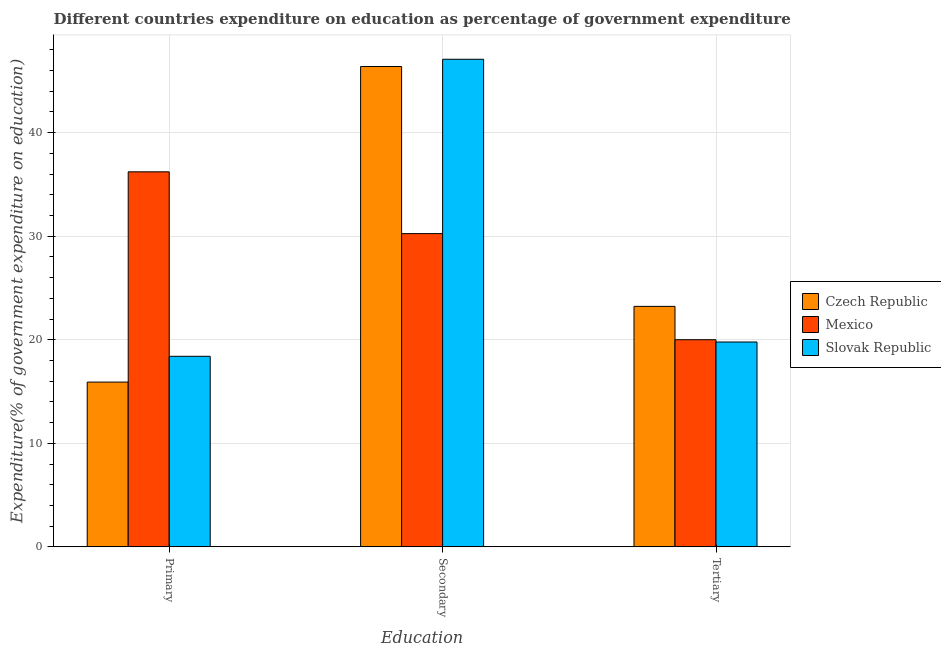How many different coloured bars are there?
Ensure brevity in your answer.  3. Are the number of bars on each tick of the X-axis equal?
Make the answer very short. Yes. How many bars are there on the 1st tick from the left?
Ensure brevity in your answer.  3. How many bars are there on the 2nd tick from the right?
Your response must be concise. 3. What is the label of the 3rd group of bars from the left?
Make the answer very short. Tertiary. What is the expenditure on tertiary education in Slovak Republic?
Keep it short and to the point. 19.78. Across all countries, what is the maximum expenditure on tertiary education?
Make the answer very short. 23.22. Across all countries, what is the minimum expenditure on tertiary education?
Ensure brevity in your answer.  19.78. In which country was the expenditure on primary education maximum?
Offer a very short reply. Mexico. What is the total expenditure on primary education in the graph?
Offer a terse response. 70.53. What is the difference between the expenditure on primary education in Czech Republic and that in Slovak Republic?
Your answer should be compact. -2.49. What is the difference between the expenditure on secondary education in Slovak Republic and the expenditure on primary education in Czech Republic?
Ensure brevity in your answer.  31.17. What is the average expenditure on tertiary education per country?
Your answer should be compact. 21. What is the difference between the expenditure on primary education and expenditure on tertiary education in Mexico?
Give a very brief answer. 16.21. What is the ratio of the expenditure on secondary education in Slovak Republic to that in Mexico?
Make the answer very short. 1.56. Is the difference between the expenditure on primary education in Czech Republic and Mexico greater than the difference between the expenditure on secondary education in Czech Republic and Mexico?
Offer a terse response. No. What is the difference between the highest and the second highest expenditure on tertiary education?
Offer a very short reply. 3.22. What is the difference between the highest and the lowest expenditure on primary education?
Offer a very short reply. 20.3. Is the sum of the expenditure on primary education in Mexico and Czech Republic greater than the maximum expenditure on tertiary education across all countries?
Provide a succinct answer. Yes. What does the 2nd bar from the left in Primary represents?
Your answer should be compact. Mexico. What does the 3rd bar from the right in Secondary represents?
Keep it short and to the point. Czech Republic. Is it the case that in every country, the sum of the expenditure on primary education and expenditure on secondary education is greater than the expenditure on tertiary education?
Your response must be concise. Yes. Are all the bars in the graph horizontal?
Offer a terse response. No. What is the difference between two consecutive major ticks on the Y-axis?
Your response must be concise. 10. Does the graph contain any zero values?
Ensure brevity in your answer.  No. Does the graph contain grids?
Provide a short and direct response. Yes. Where does the legend appear in the graph?
Your answer should be very brief. Center right. What is the title of the graph?
Ensure brevity in your answer.  Different countries expenditure on education as percentage of government expenditure. Does "Korea (Republic)" appear as one of the legend labels in the graph?
Make the answer very short. No. What is the label or title of the X-axis?
Offer a very short reply. Education. What is the label or title of the Y-axis?
Offer a terse response. Expenditure(% of government expenditure on education). What is the Expenditure(% of government expenditure on education) in Czech Republic in Primary?
Your response must be concise. 15.91. What is the Expenditure(% of government expenditure on education) in Mexico in Primary?
Your answer should be compact. 36.22. What is the Expenditure(% of government expenditure on education) of Slovak Republic in Primary?
Provide a succinct answer. 18.4. What is the Expenditure(% of government expenditure on education) of Czech Republic in Secondary?
Keep it short and to the point. 46.39. What is the Expenditure(% of government expenditure on education) in Mexico in Secondary?
Offer a very short reply. 30.25. What is the Expenditure(% of government expenditure on education) of Slovak Republic in Secondary?
Ensure brevity in your answer.  47.09. What is the Expenditure(% of government expenditure on education) of Czech Republic in Tertiary?
Offer a very short reply. 23.22. What is the Expenditure(% of government expenditure on education) of Mexico in Tertiary?
Your response must be concise. 20. What is the Expenditure(% of government expenditure on education) in Slovak Republic in Tertiary?
Make the answer very short. 19.78. Across all Education, what is the maximum Expenditure(% of government expenditure on education) in Czech Republic?
Provide a succinct answer. 46.39. Across all Education, what is the maximum Expenditure(% of government expenditure on education) in Mexico?
Your response must be concise. 36.22. Across all Education, what is the maximum Expenditure(% of government expenditure on education) of Slovak Republic?
Your answer should be compact. 47.09. Across all Education, what is the minimum Expenditure(% of government expenditure on education) of Czech Republic?
Provide a succinct answer. 15.91. Across all Education, what is the minimum Expenditure(% of government expenditure on education) in Mexico?
Your answer should be compact. 20. Across all Education, what is the minimum Expenditure(% of government expenditure on education) of Slovak Republic?
Your response must be concise. 18.4. What is the total Expenditure(% of government expenditure on education) in Czech Republic in the graph?
Provide a succinct answer. 85.52. What is the total Expenditure(% of government expenditure on education) in Mexico in the graph?
Make the answer very short. 86.47. What is the total Expenditure(% of government expenditure on education) in Slovak Republic in the graph?
Your response must be concise. 85.27. What is the difference between the Expenditure(% of government expenditure on education) of Czech Republic in Primary and that in Secondary?
Your response must be concise. -30.47. What is the difference between the Expenditure(% of government expenditure on education) of Mexico in Primary and that in Secondary?
Make the answer very short. 5.97. What is the difference between the Expenditure(% of government expenditure on education) in Slovak Republic in Primary and that in Secondary?
Keep it short and to the point. -28.69. What is the difference between the Expenditure(% of government expenditure on education) in Czech Republic in Primary and that in Tertiary?
Your response must be concise. -7.31. What is the difference between the Expenditure(% of government expenditure on education) of Mexico in Primary and that in Tertiary?
Make the answer very short. 16.21. What is the difference between the Expenditure(% of government expenditure on education) of Slovak Republic in Primary and that in Tertiary?
Provide a short and direct response. -1.38. What is the difference between the Expenditure(% of government expenditure on education) of Czech Republic in Secondary and that in Tertiary?
Make the answer very short. 23.16. What is the difference between the Expenditure(% of government expenditure on education) of Mexico in Secondary and that in Tertiary?
Your response must be concise. 10.25. What is the difference between the Expenditure(% of government expenditure on education) in Slovak Republic in Secondary and that in Tertiary?
Your answer should be very brief. 27.3. What is the difference between the Expenditure(% of government expenditure on education) of Czech Republic in Primary and the Expenditure(% of government expenditure on education) of Mexico in Secondary?
Make the answer very short. -14.34. What is the difference between the Expenditure(% of government expenditure on education) of Czech Republic in Primary and the Expenditure(% of government expenditure on education) of Slovak Republic in Secondary?
Provide a succinct answer. -31.17. What is the difference between the Expenditure(% of government expenditure on education) of Mexico in Primary and the Expenditure(% of government expenditure on education) of Slovak Republic in Secondary?
Ensure brevity in your answer.  -10.87. What is the difference between the Expenditure(% of government expenditure on education) of Czech Republic in Primary and the Expenditure(% of government expenditure on education) of Mexico in Tertiary?
Ensure brevity in your answer.  -4.09. What is the difference between the Expenditure(% of government expenditure on education) of Czech Republic in Primary and the Expenditure(% of government expenditure on education) of Slovak Republic in Tertiary?
Offer a very short reply. -3.87. What is the difference between the Expenditure(% of government expenditure on education) of Mexico in Primary and the Expenditure(% of government expenditure on education) of Slovak Republic in Tertiary?
Keep it short and to the point. 16.43. What is the difference between the Expenditure(% of government expenditure on education) in Czech Republic in Secondary and the Expenditure(% of government expenditure on education) in Mexico in Tertiary?
Keep it short and to the point. 26.38. What is the difference between the Expenditure(% of government expenditure on education) in Czech Republic in Secondary and the Expenditure(% of government expenditure on education) in Slovak Republic in Tertiary?
Offer a terse response. 26.6. What is the difference between the Expenditure(% of government expenditure on education) in Mexico in Secondary and the Expenditure(% of government expenditure on education) in Slovak Republic in Tertiary?
Make the answer very short. 10.47. What is the average Expenditure(% of government expenditure on education) of Czech Republic per Education?
Give a very brief answer. 28.51. What is the average Expenditure(% of government expenditure on education) of Mexico per Education?
Ensure brevity in your answer.  28.82. What is the average Expenditure(% of government expenditure on education) in Slovak Republic per Education?
Make the answer very short. 28.42. What is the difference between the Expenditure(% of government expenditure on education) in Czech Republic and Expenditure(% of government expenditure on education) in Mexico in Primary?
Provide a succinct answer. -20.3. What is the difference between the Expenditure(% of government expenditure on education) of Czech Republic and Expenditure(% of government expenditure on education) of Slovak Republic in Primary?
Offer a terse response. -2.49. What is the difference between the Expenditure(% of government expenditure on education) in Mexico and Expenditure(% of government expenditure on education) in Slovak Republic in Primary?
Offer a terse response. 17.82. What is the difference between the Expenditure(% of government expenditure on education) in Czech Republic and Expenditure(% of government expenditure on education) in Mexico in Secondary?
Your answer should be compact. 16.14. What is the difference between the Expenditure(% of government expenditure on education) in Czech Republic and Expenditure(% of government expenditure on education) in Slovak Republic in Secondary?
Provide a short and direct response. -0.7. What is the difference between the Expenditure(% of government expenditure on education) of Mexico and Expenditure(% of government expenditure on education) of Slovak Republic in Secondary?
Your answer should be compact. -16.84. What is the difference between the Expenditure(% of government expenditure on education) of Czech Republic and Expenditure(% of government expenditure on education) of Mexico in Tertiary?
Ensure brevity in your answer.  3.22. What is the difference between the Expenditure(% of government expenditure on education) of Czech Republic and Expenditure(% of government expenditure on education) of Slovak Republic in Tertiary?
Your answer should be very brief. 3.44. What is the difference between the Expenditure(% of government expenditure on education) in Mexico and Expenditure(% of government expenditure on education) in Slovak Republic in Tertiary?
Offer a very short reply. 0.22. What is the ratio of the Expenditure(% of government expenditure on education) in Czech Republic in Primary to that in Secondary?
Give a very brief answer. 0.34. What is the ratio of the Expenditure(% of government expenditure on education) of Mexico in Primary to that in Secondary?
Give a very brief answer. 1.2. What is the ratio of the Expenditure(% of government expenditure on education) in Slovak Republic in Primary to that in Secondary?
Offer a very short reply. 0.39. What is the ratio of the Expenditure(% of government expenditure on education) in Czech Republic in Primary to that in Tertiary?
Make the answer very short. 0.69. What is the ratio of the Expenditure(% of government expenditure on education) in Mexico in Primary to that in Tertiary?
Keep it short and to the point. 1.81. What is the ratio of the Expenditure(% of government expenditure on education) of Slovak Republic in Primary to that in Tertiary?
Give a very brief answer. 0.93. What is the ratio of the Expenditure(% of government expenditure on education) in Czech Republic in Secondary to that in Tertiary?
Offer a very short reply. 2. What is the ratio of the Expenditure(% of government expenditure on education) in Mexico in Secondary to that in Tertiary?
Offer a terse response. 1.51. What is the ratio of the Expenditure(% of government expenditure on education) of Slovak Republic in Secondary to that in Tertiary?
Keep it short and to the point. 2.38. What is the difference between the highest and the second highest Expenditure(% of government expenditure on education) in Czech Republic?
Provide a succinct answer. 23.16. What is the difference between the highest and the second highest Expenditure(% of government expenditure on education) in Mexico?
Make the answer very short. 5.97. What is the difference between the highest and the second highest Expenditure(% of government expenditure on education) of Slovak Republic?
Your answer should be very brief. 27.3. What is the difference between the highest and the lowest Expenditure(% of government expenditure on education) in Czech Republic?
Keep it short and to the point. 30.47. What is the difference between the highest and the lowest Expenditure(% of government expenditure on education) in Mexico?
Provide a succinct answer. 16.21. What is the difference between the highest and the lowest Expenditure(% of government expenditure on education) in Slovak Republic?
Your response must be concise. 28.69. 